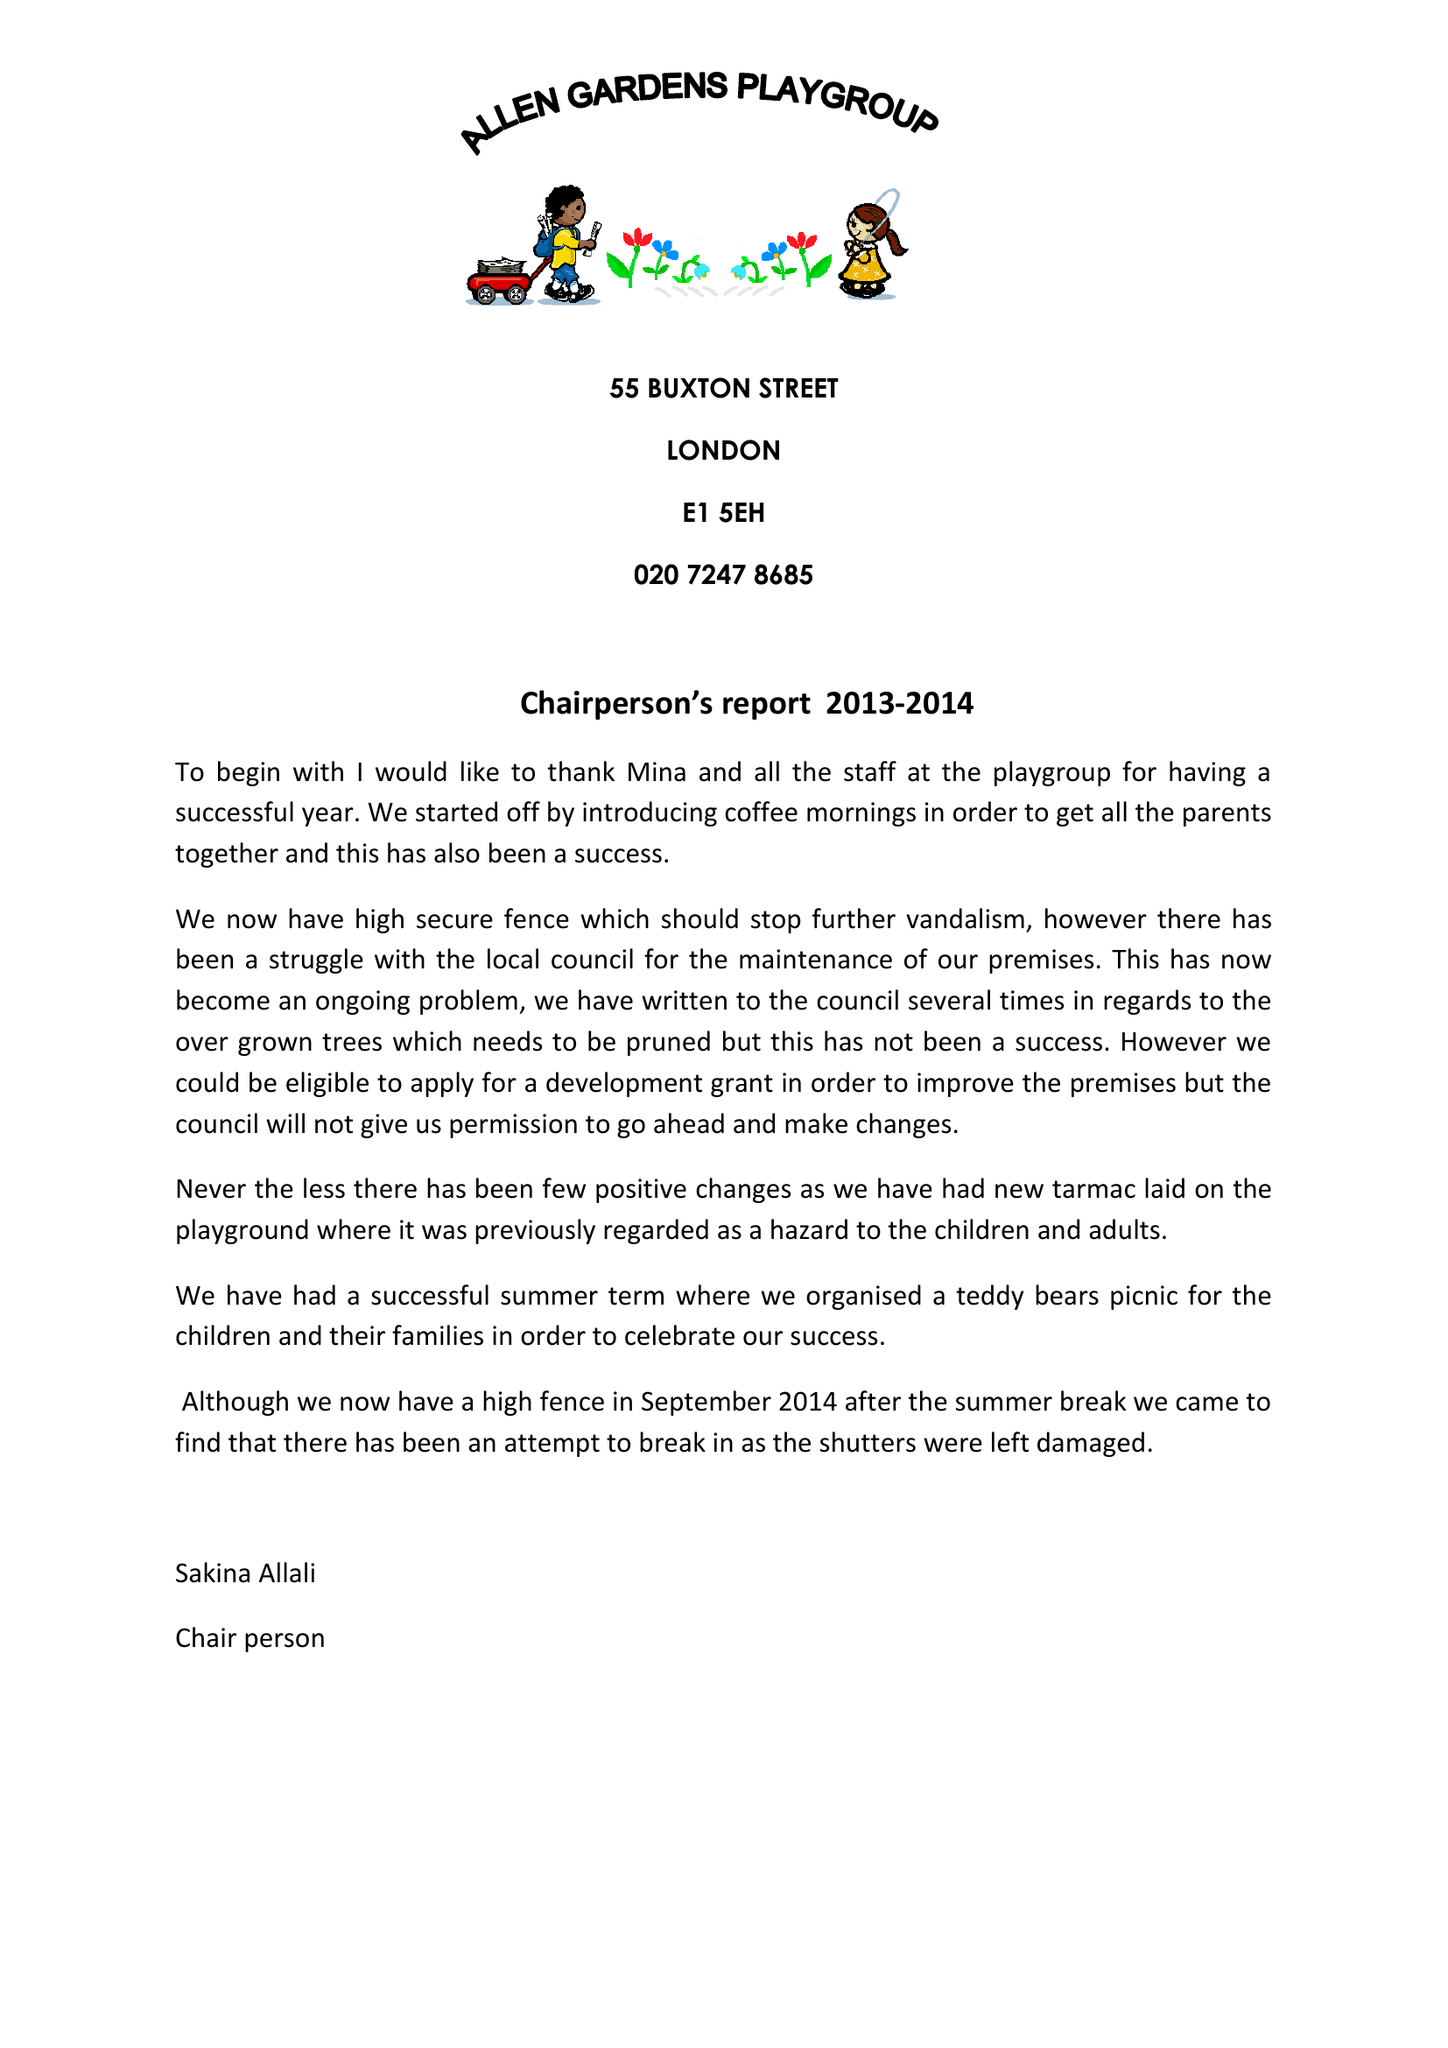What is the value for the income_annually_in_british_pounds?
Answer the question using a single word or phrase. 197905.00 